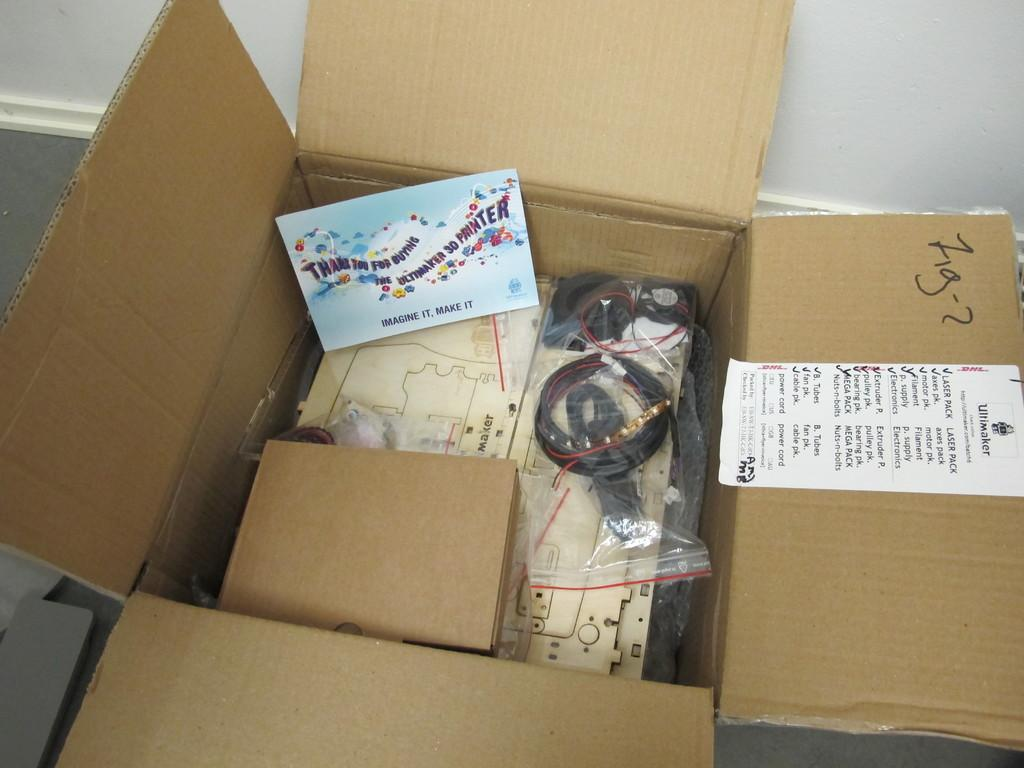Provide a one-sentence caption for the provided image. The shipment of the contents of this box are from Wiltmaker. 